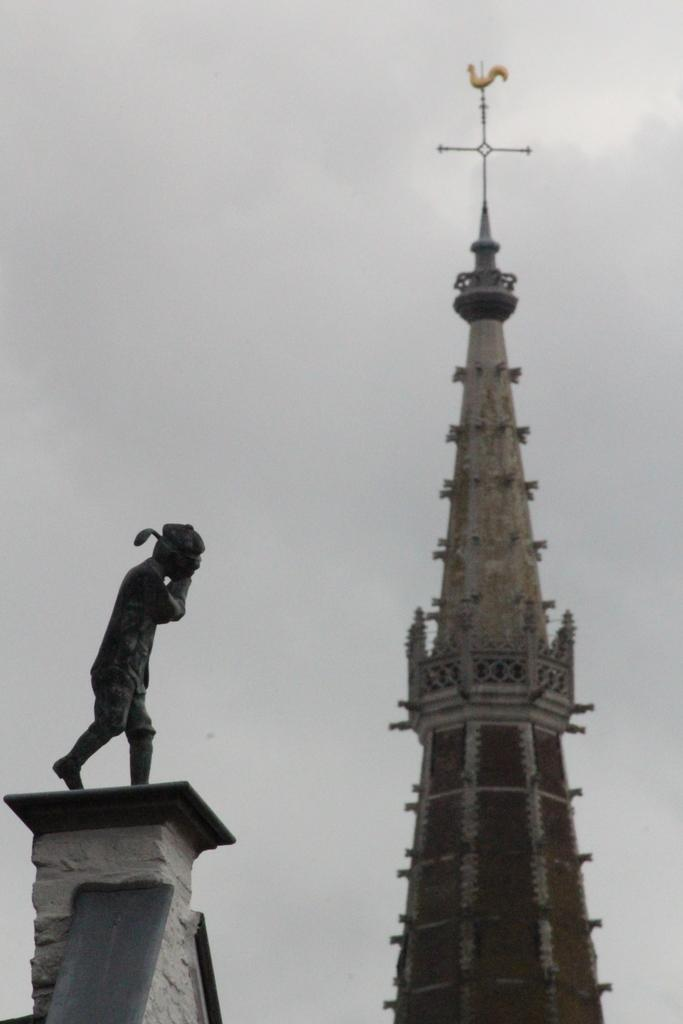What structure is located on the right side of the image? There is a tower on the right side of the image. What can be seen on the left side of the image? There is a statue on a building on the left side of the image. What is visible in the image besides the tower and statue? The sky is visible in the image. What can be observed in the sky? Clouds are present in the sky. Can you tell me how many rivers are flowing near the tower in the image? There are no rivers present in the image; it features a tower and a statue on a building. What type of headwear is the statue wearing in the image? There is no headwear visible on the statue in the image. 